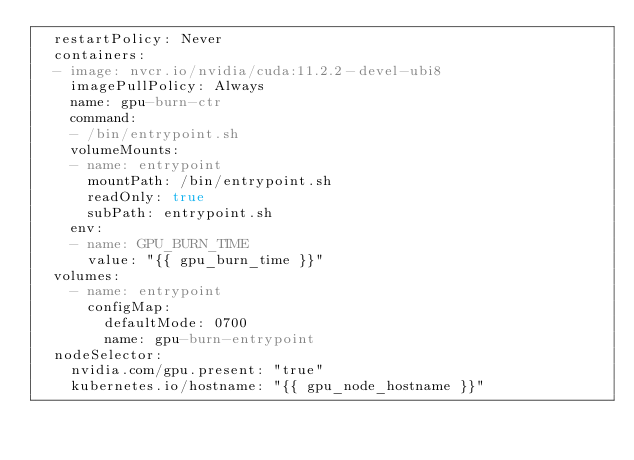<code> <loc_0><loc_0><loc_500><loc_500><_YAML_>  restartPolicy: Never
  containers:
  - image: nvcr.io/nvidia/cuda:11.2.2-devel-ubi8
    imagePullPolicy: Always
    name: gpu-burn-ctr
    command:
    - /bin/entrypoint.sh
    volumeMounts:
    - name: entrypoint
      mountPath: /bin/entrypoint.sh
      readOnly: true
      subPath: entrypoint.sh
    env:
    - name: GPU_BURN_TIME
      value: "{{ gpu_burn_time }}"
  volumes:
    - name: entrypoint
      configMap:
        defaultMode: 0700
        name: gpu-burn-entrypoint
  nodeSelector:
    nvidia.com/gpu.present: "true"
    kubernetes.io/hostname: "{{ gpu_node_hostname }}"
</code> 